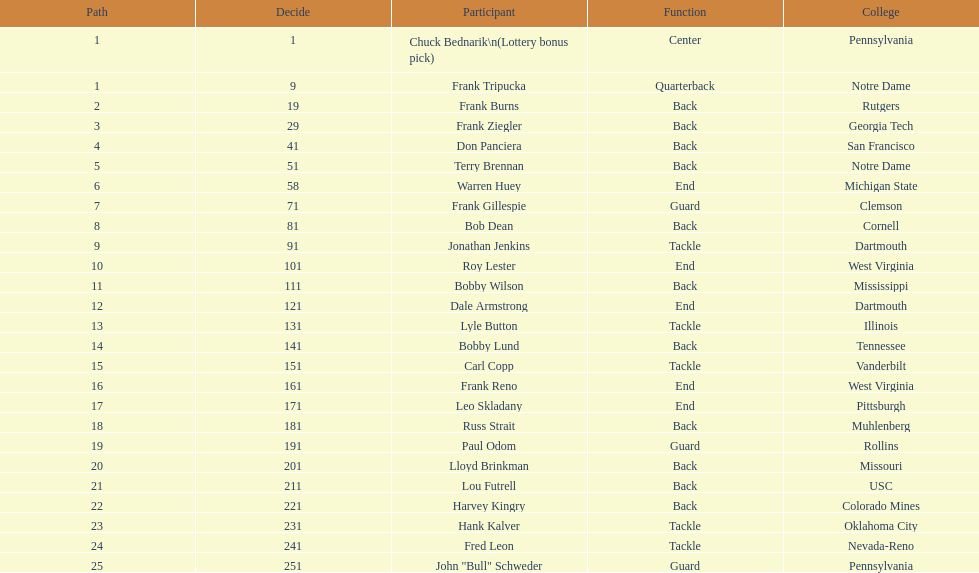Who has same position as frank gillespie? Paul Odom, John "Bull" Schweder. 